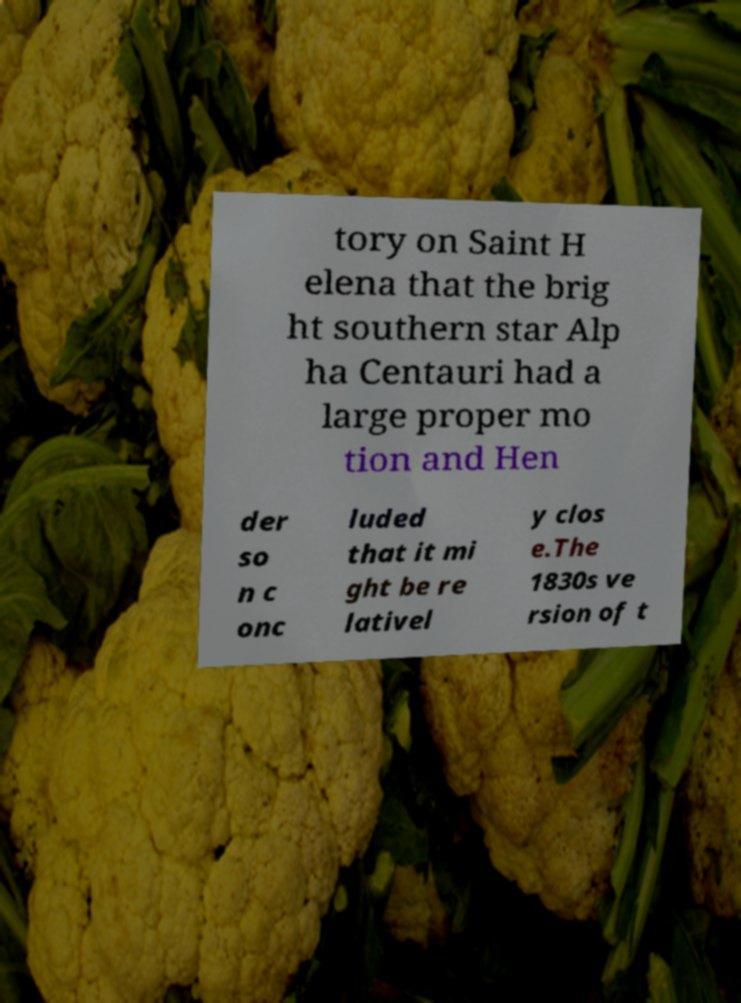Please read and relay the text visible in this image. What does it say? tory on Saint H elena that the brig ht southern star Alp ha Centauri had a large proper mo tion and Hen der so n c onc luded that it mi ght be re lativel y clos e.The 1830s ve rsion of t 